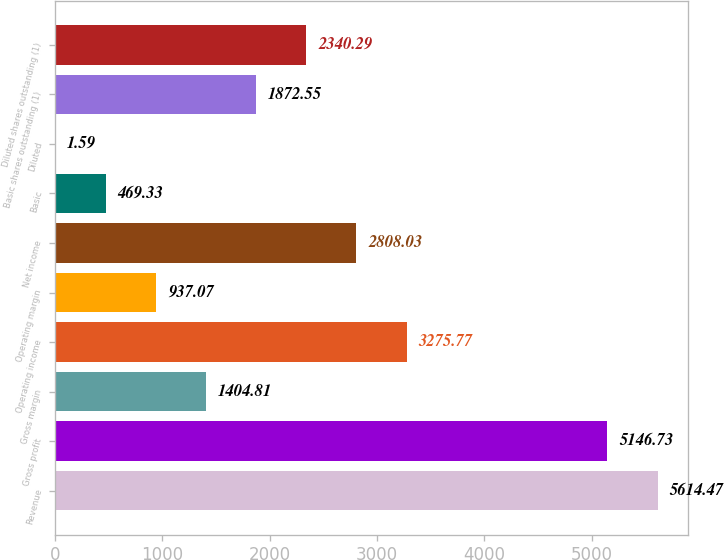Convert chart. <chart><loc_0><loc_0><loc_500><loc_500><bar_chart><fcel>Revenue<fcel>Gross profit<fcel>Gross margin<fcel>Operating income<fcel>Operating margin<fcel>Net income<fcel>Basic<fcel>Diluted<fcel>Basic shares outstanding (1)<fcel>Diluted shares outstanding (1)<nl><fcel>5614.47<fcel>5146.73<fcel>1404.81<fcel>3275.77<fcel>937.07<fcel>2808.03<fcel>469.33<fcel>1.59<fcel>1872.55<fcel>2340.29<nl></chart> 